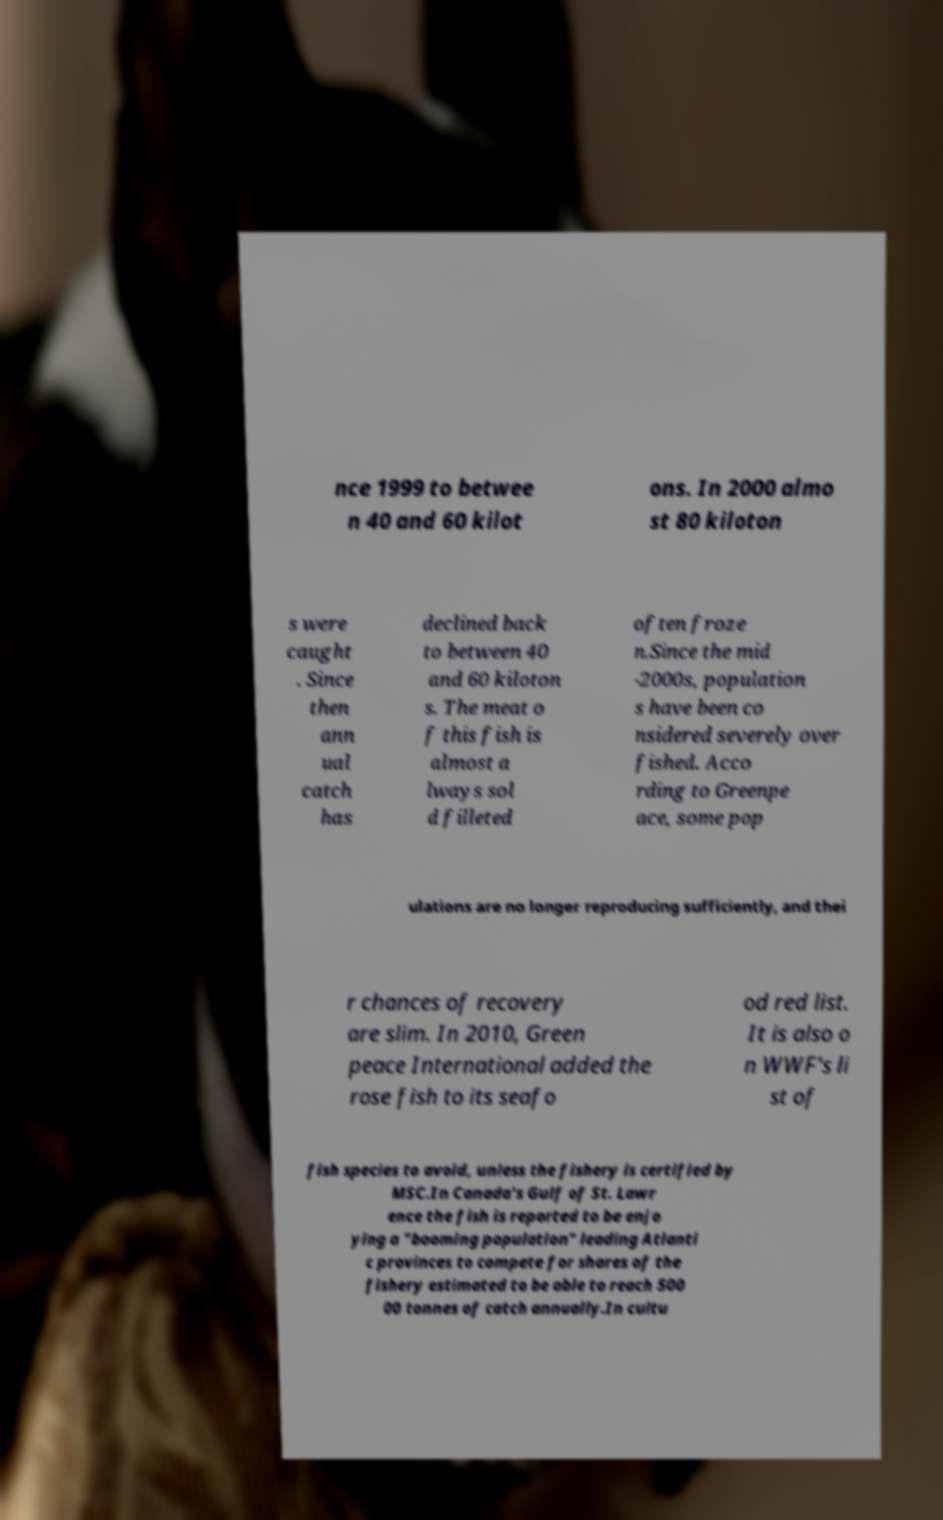There's text embedded in this image that I need extracted. Can you transcribe it verbatim? nce 1999 to betwee n 40 and 60 kilot ons. In 2000 almo st 80 kiloton s were caught . Since then ann ual catch has declined back to between 40 and 60 kiloton s. The meat o f this fish is almost a lways sol d filleted often froze n.Since the mid -2000s, population s have been co nsidered severely over fished. Acco rding to Greenpe ace, some pop ulations are no longer reproducing sufficiently, and thei r chances of recovery are slim. In 2010, Green peace International added the rose fish to its seafo od red list. It is also o n WWF's li st of fish species to avoid, unless the fishery is certified by MSC.In Canada's Gulf of St. Lawr ence the fish is reported to be enjo ying a "booming population" leading Atlanti c provinces to compete for shares of the fishery estimated to be able to reach 500 00 tonnes of catch annually.In cultu 